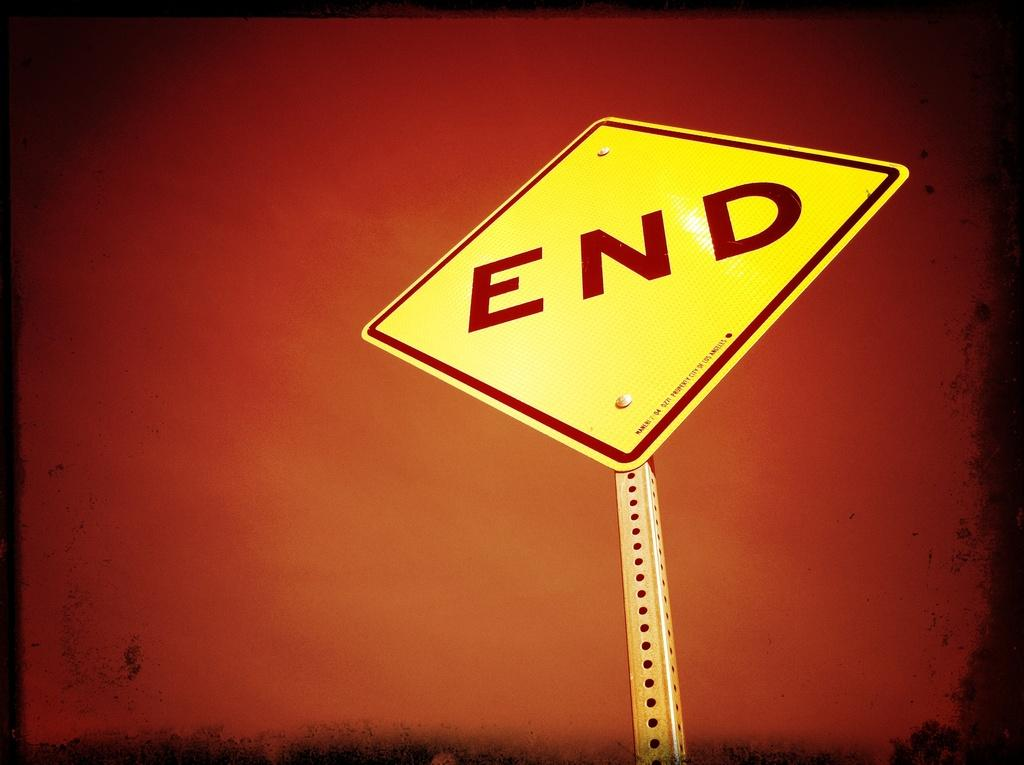<image>
Render a clear and concise summary of the photo. A yellow sign indicating the end in front of an orange sky. 